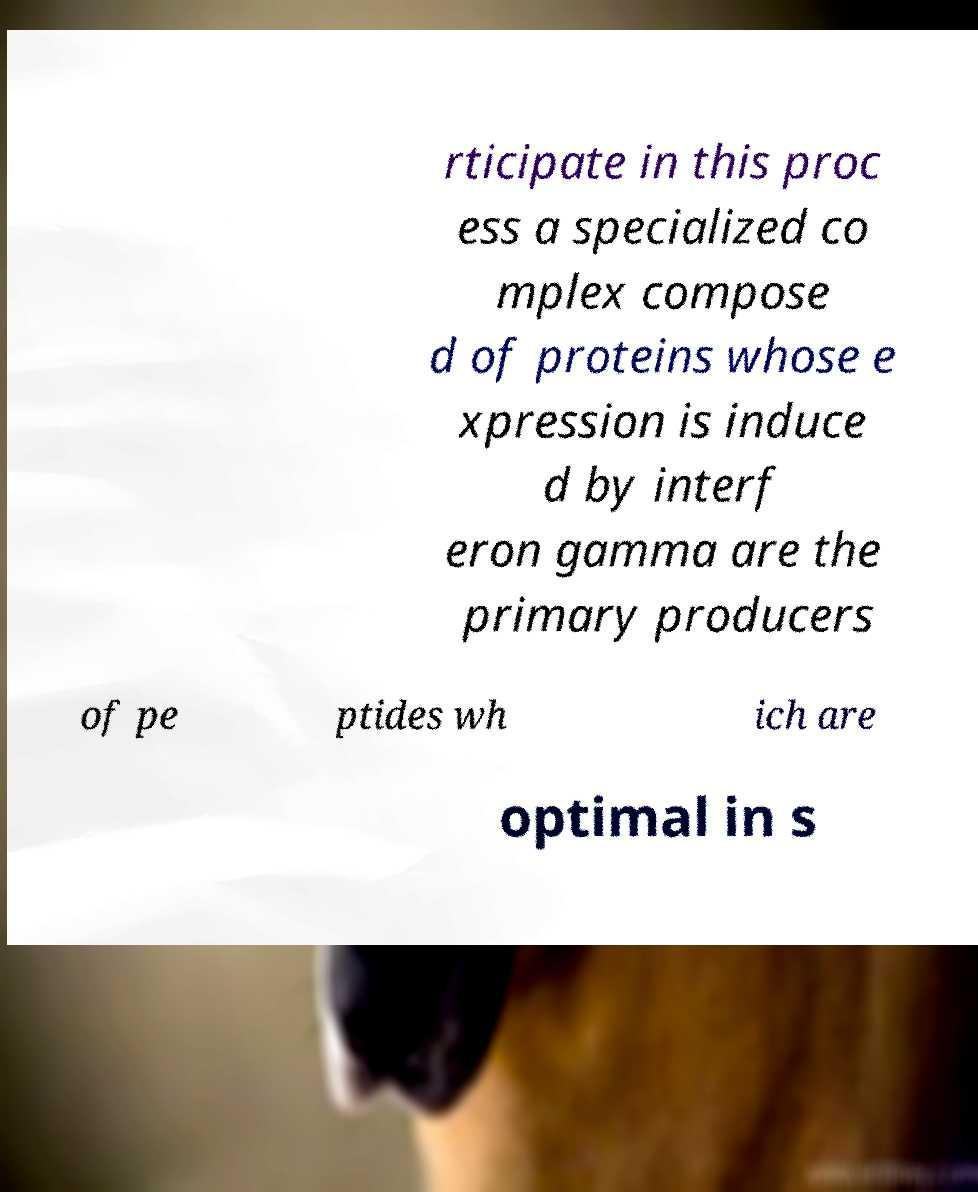What messages or text are displayed in this image? I need them in a readable, typed format. rticipate in this proc ess a specialized co mplex compose d of proteins whose e xpression is induce d by interf eron gamma are the primary producers of pe ptides wh ich are optimal in s 